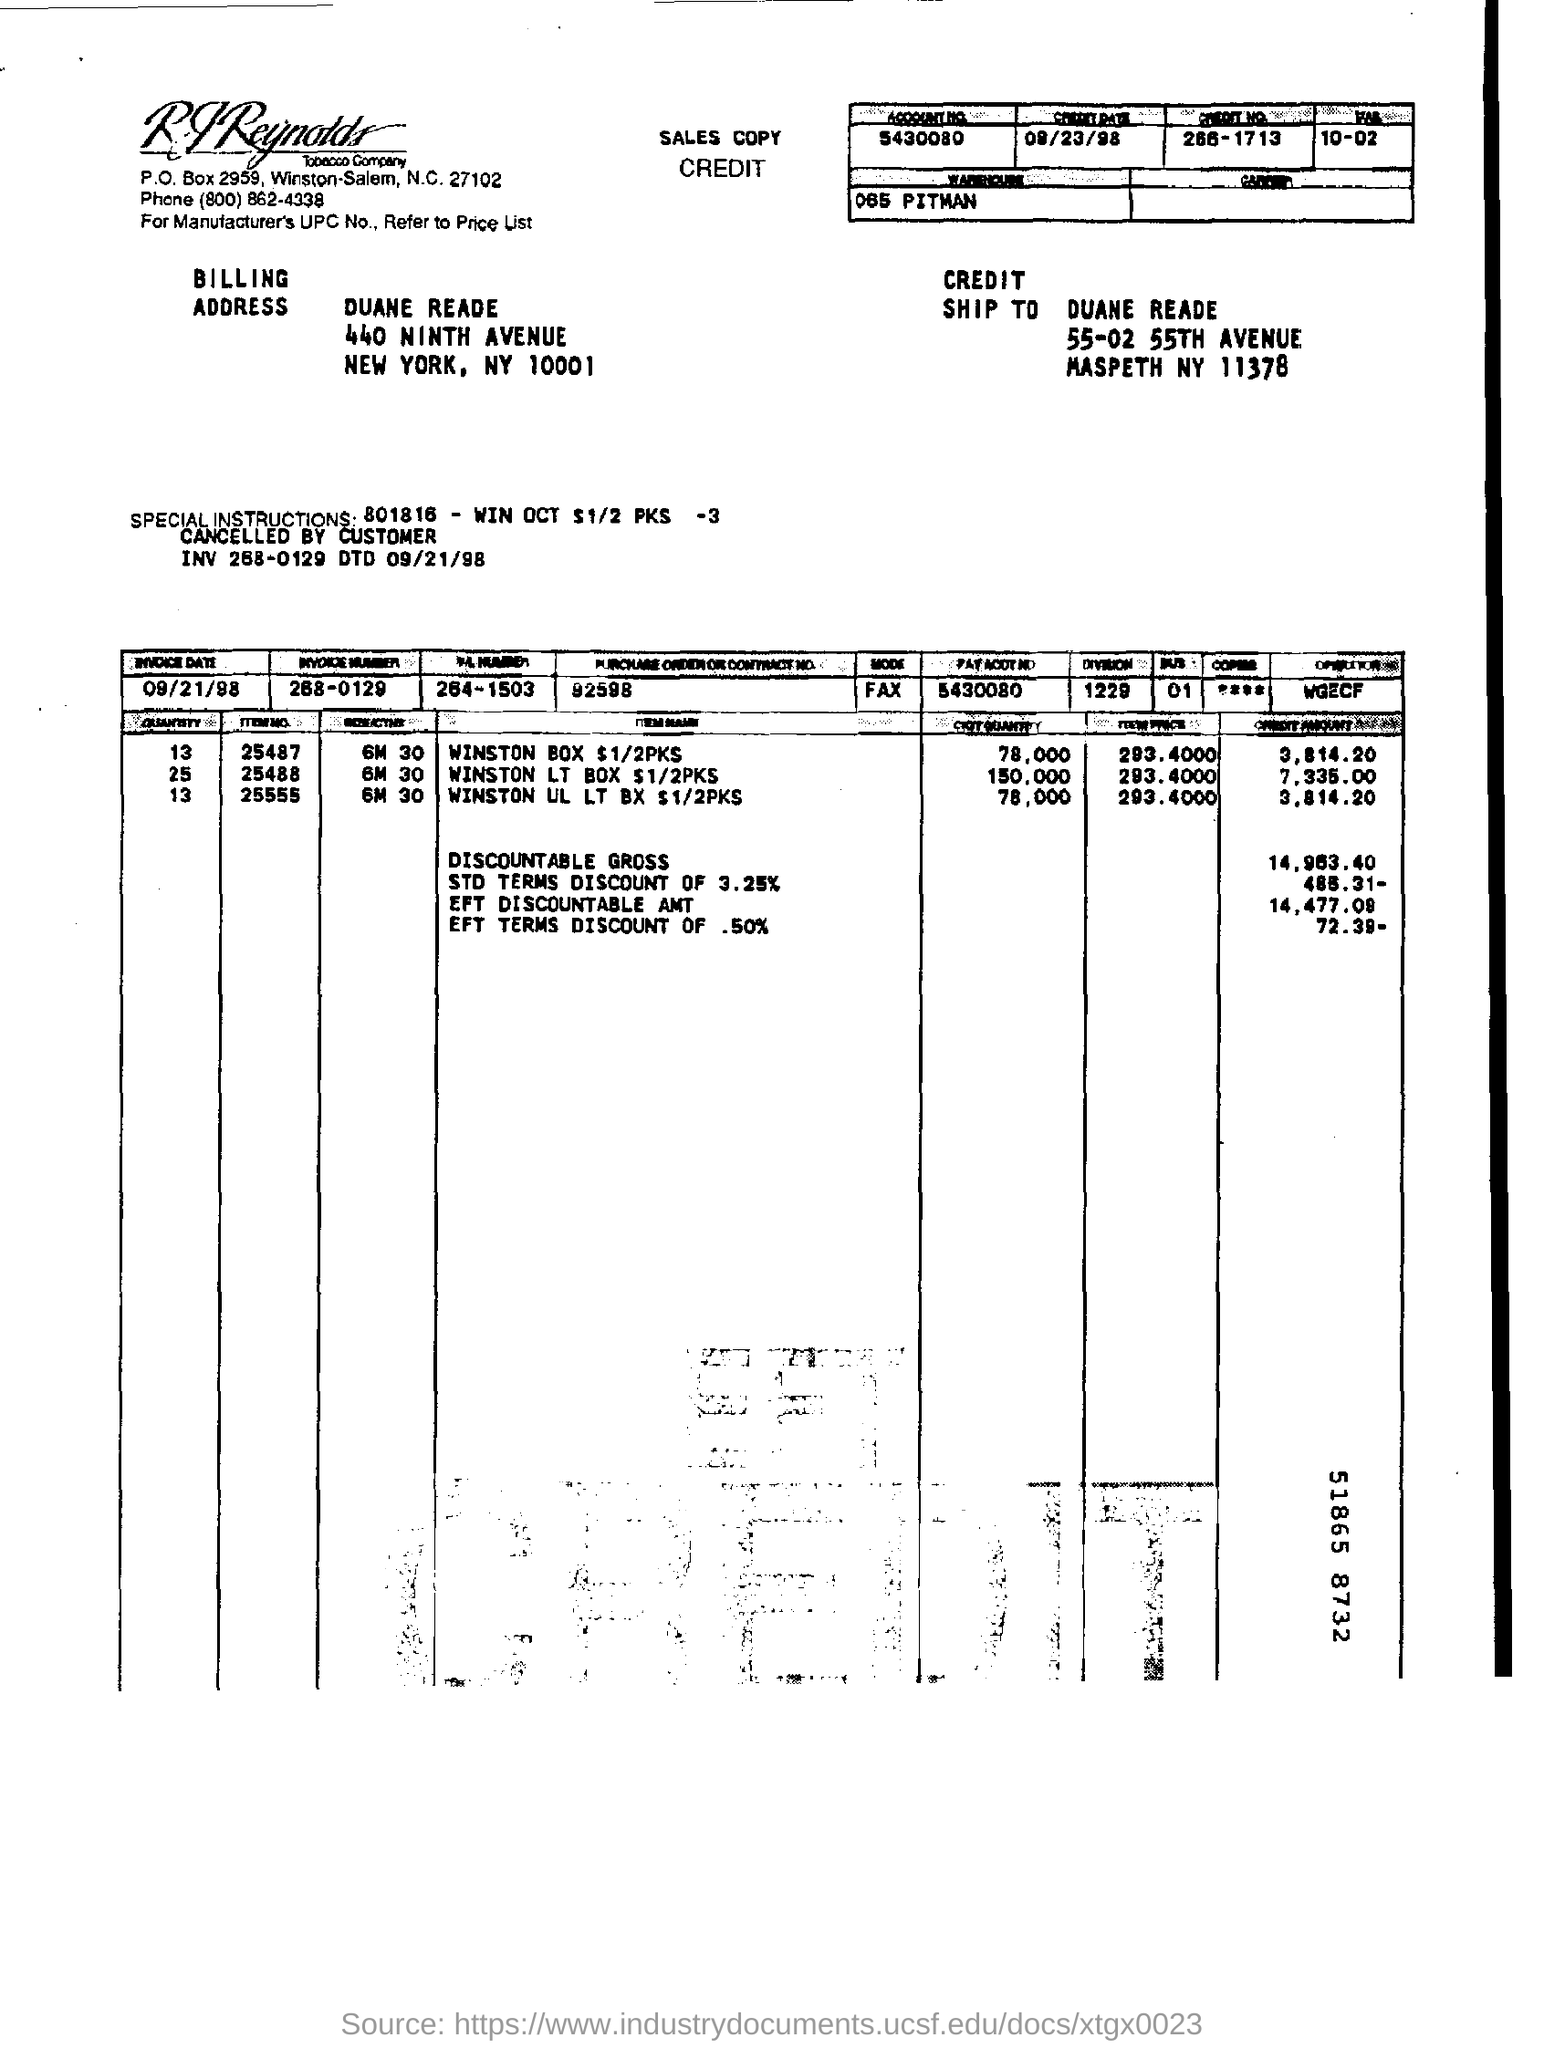Indicate a few pertinent items in this graphic. The invoice number is 268-0129. What is the account number?" the customer asked. "It is 5430080..." the customer replied. The credit date is September 23, 1998. The credit number is 266-1713. 